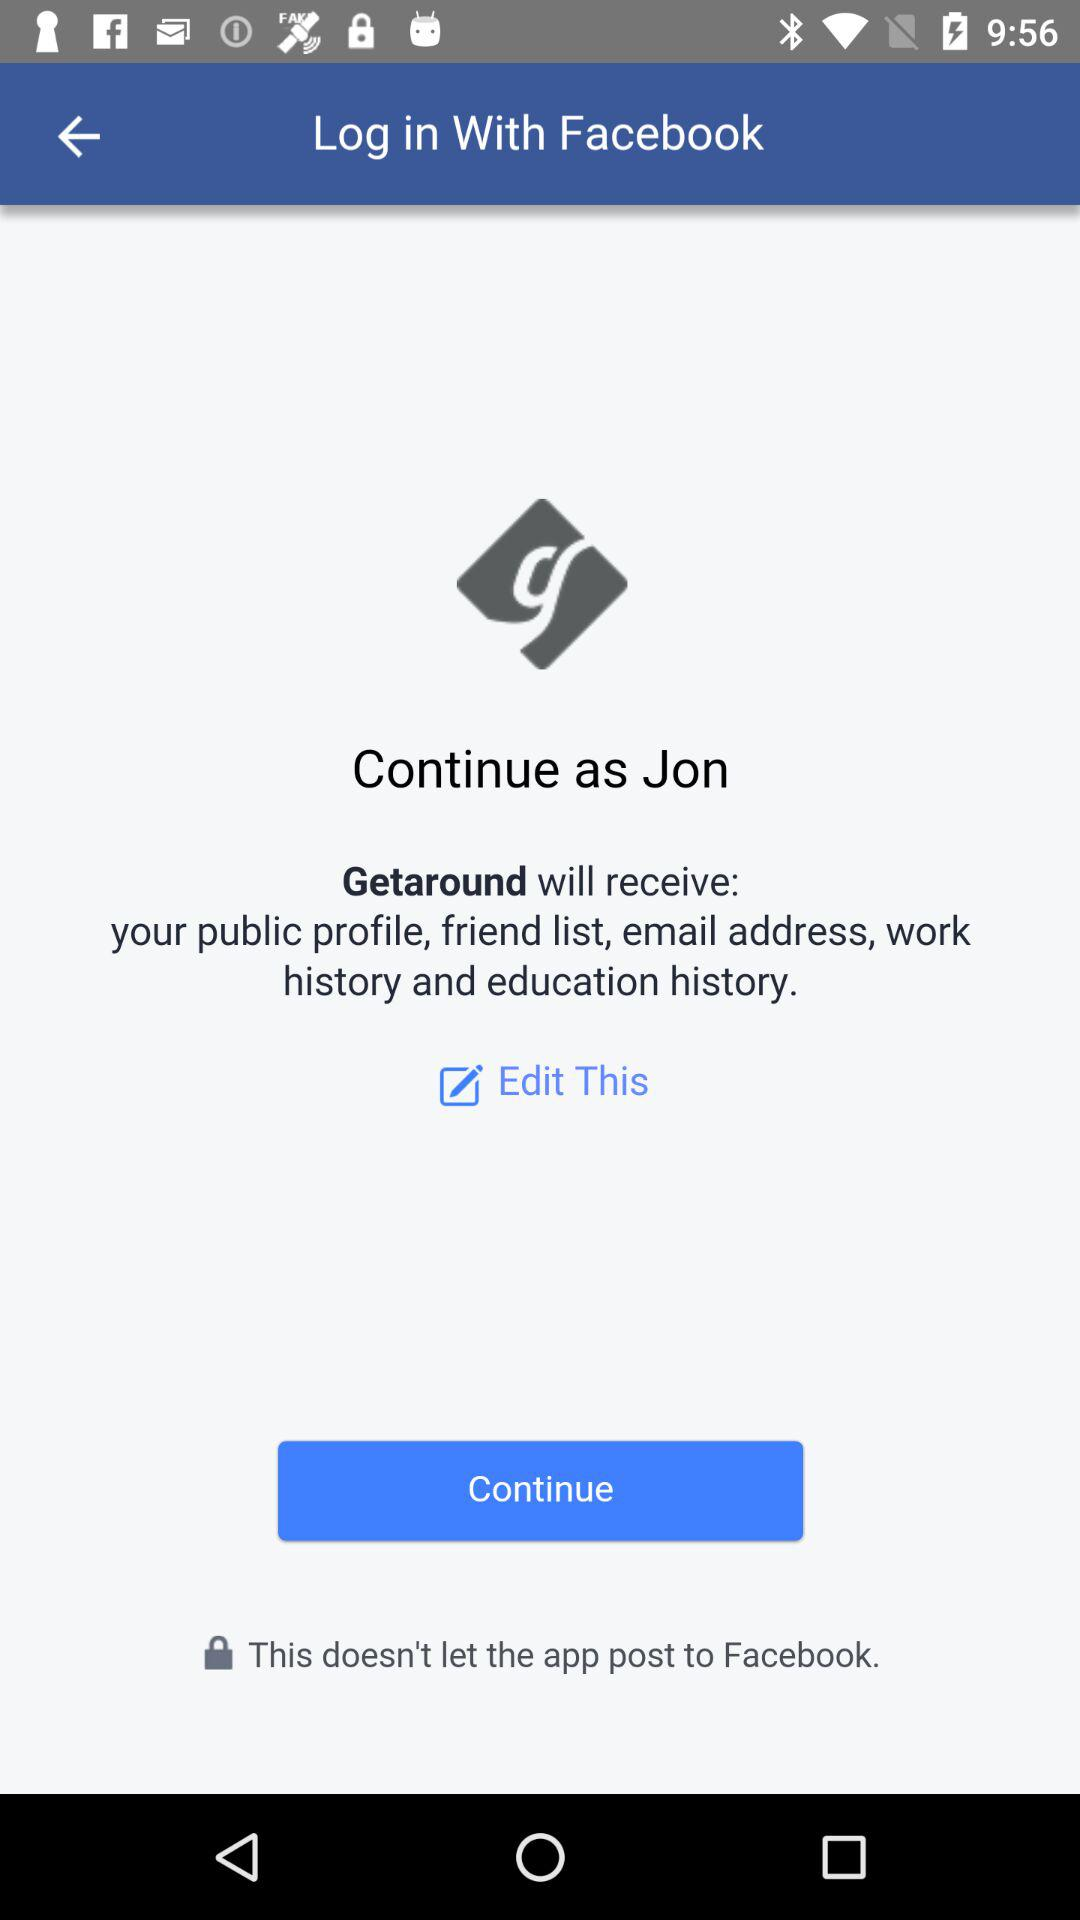What is the user name? The user name is Jon. 